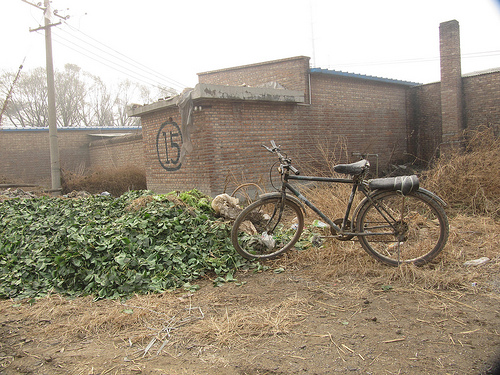<image>
Is there a bike next to the bush? Yes. The bike is positioned adjacent to the bush, located nearby in the same general area. 